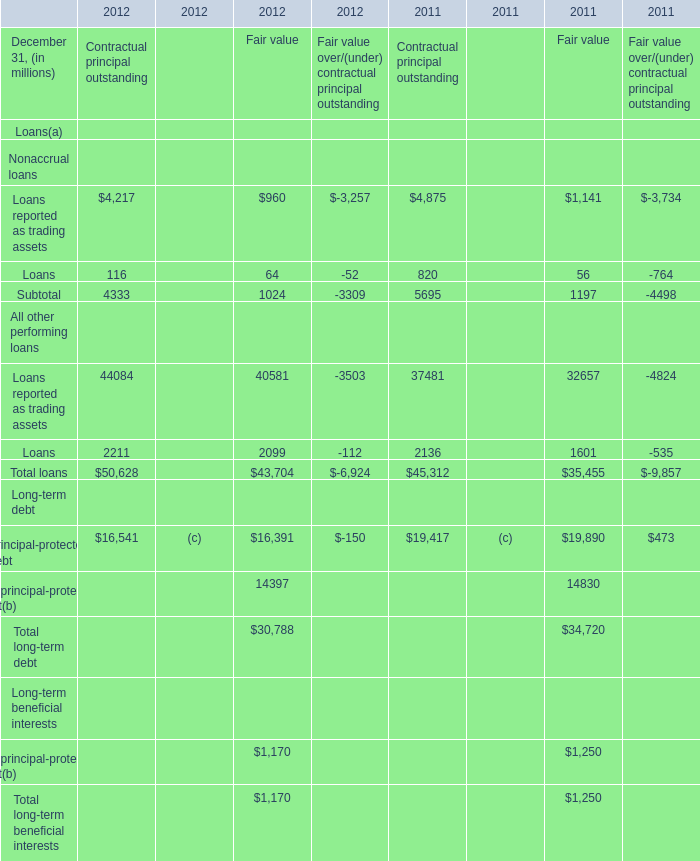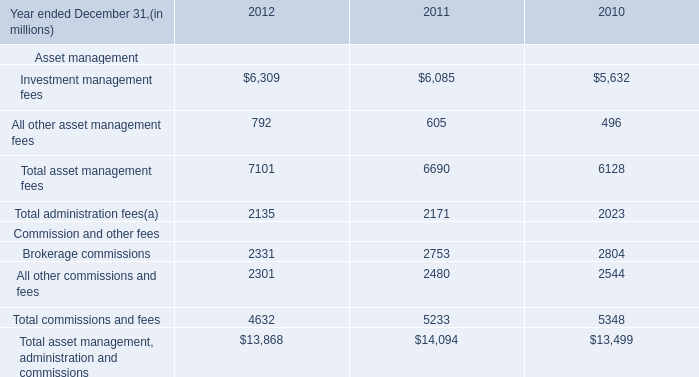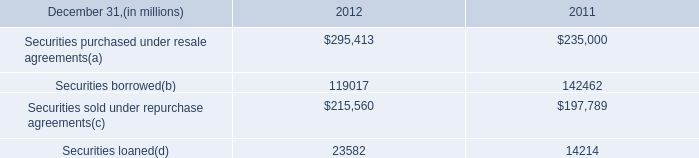What's the sum of all elements for Fair value that are greater than 10000 in 2011? (in million) 
Computations: ((32657 + 19890) + 14830)
Answer: 67377.0. 